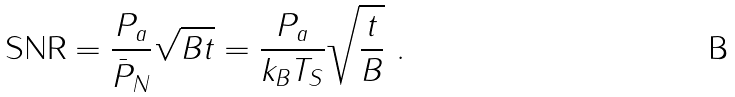Convert formula to latex. <formula><loc_0><loc_0><loc_500><loc_500>\text {SNR} = \frac { P _ { a } } { \bar { P } _ { N } } \sqrt { B t } = \frac { P _ { a } } { k _ { B } T _ { S } } \sqrt { \frac { t } { B } } \ .</formula> 